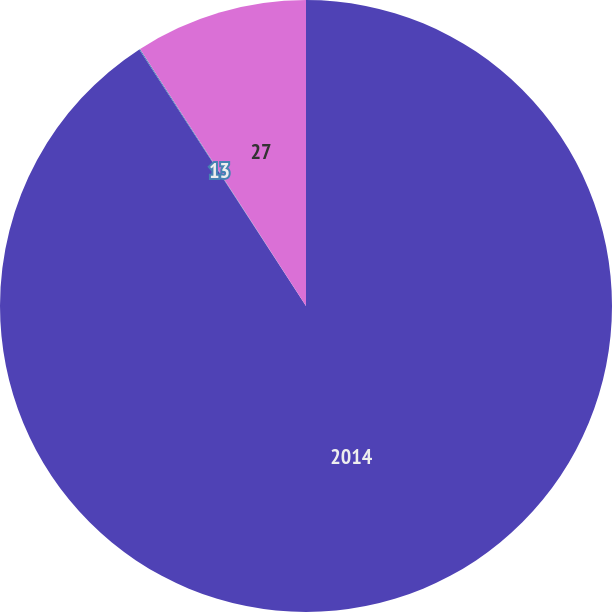Convert chart. <chart><loc_0><loc_0><loc_500><loc_500><pie_chart><fcel>2014<fcel>13<fcel>27<nl><fcel>90.83%<fcel>0.05%<fcel>9.12%<nl></chart> 